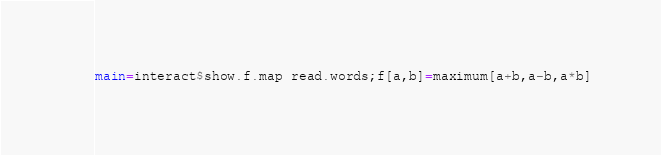<code> <loc_0><loc_0><loc_500><loc_500><_Haskell_>main=interact$show.f.map read.words;f[a,b]=maximum[a+b,a-b,a*b]</code> 